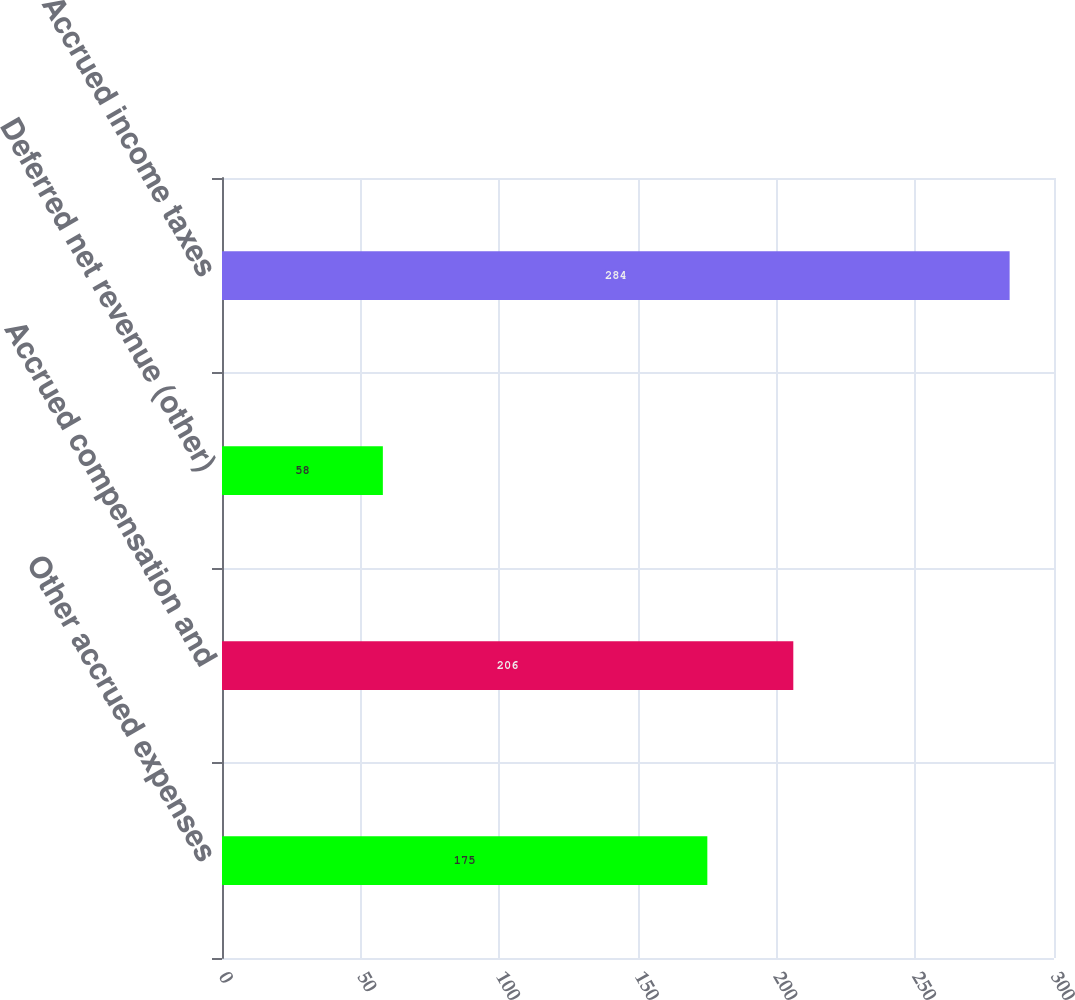Convert chart. <chart><loc_0><loc_0><loc_500><loc_500><bar_chart><fcel>Other accrued expenses<fcel>Accrued compensation and<fcel>Deferred net revenue (other)<fcel>Accrued income taxes<nl><fcel>175<fcel>206<fcel>58<fcel>284<nl></chart> 